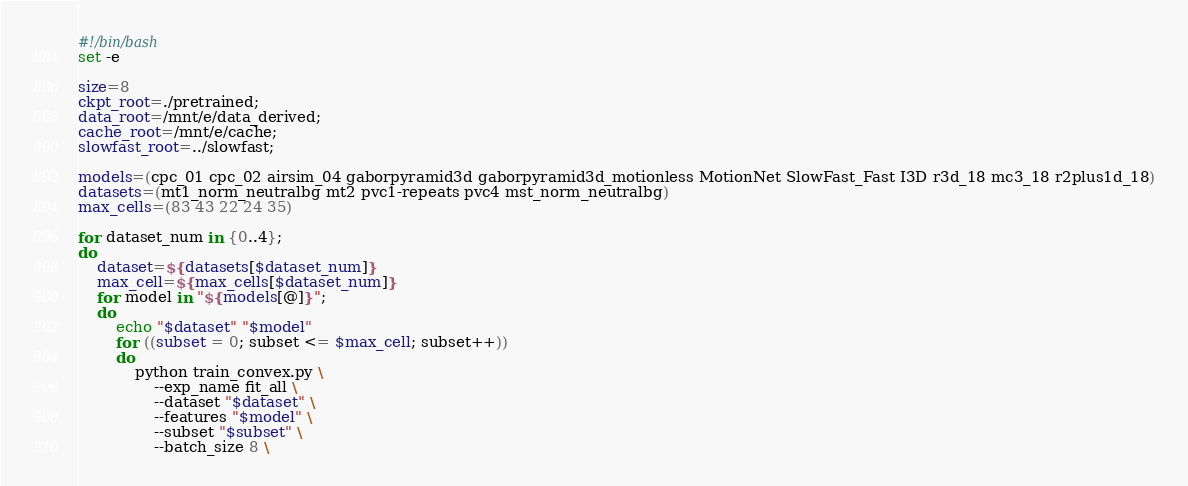<code> <loc_0><loc_0><loc_500><loc_500><_Bash_>#!/bin/bash
set -e

size=8
ckpt_root=./pretrained;
data_root=/mnt/e/data_derived;
cache_root=/mnt/e/cache;
slowfast_root=../slowfast;

models=(cpc_01 cpc_02 airsim_04 gaborpyramid3d gaborpyramid3d_motionless MotionNet SlowFast_Fast I3D r3d_18 mc3_18 r2plus1d_18)
datasets=(mt1_norm_neutralbg mt2 pvc1-repeats pvc4 mst_norm_neutralbg)
max_cells=(83 43 22 24 35)

for dataset_num in {0..4};
do
    dataset=${datasets[$dataset_num]}
    max_cell=${max_cells[$dataset_num]}
    for model in "${models[@]}";
    do
        echo "$dataset" "$model"
        for ((subset = 0; subset <= $max_cell; subset++))
        do
            python train_convex.py \
                --exp_name fit_all \
                --dataset "$dataset" \
                --features "$model" \
                --subset "$subset" \
                --batch_size 8 \</code> 